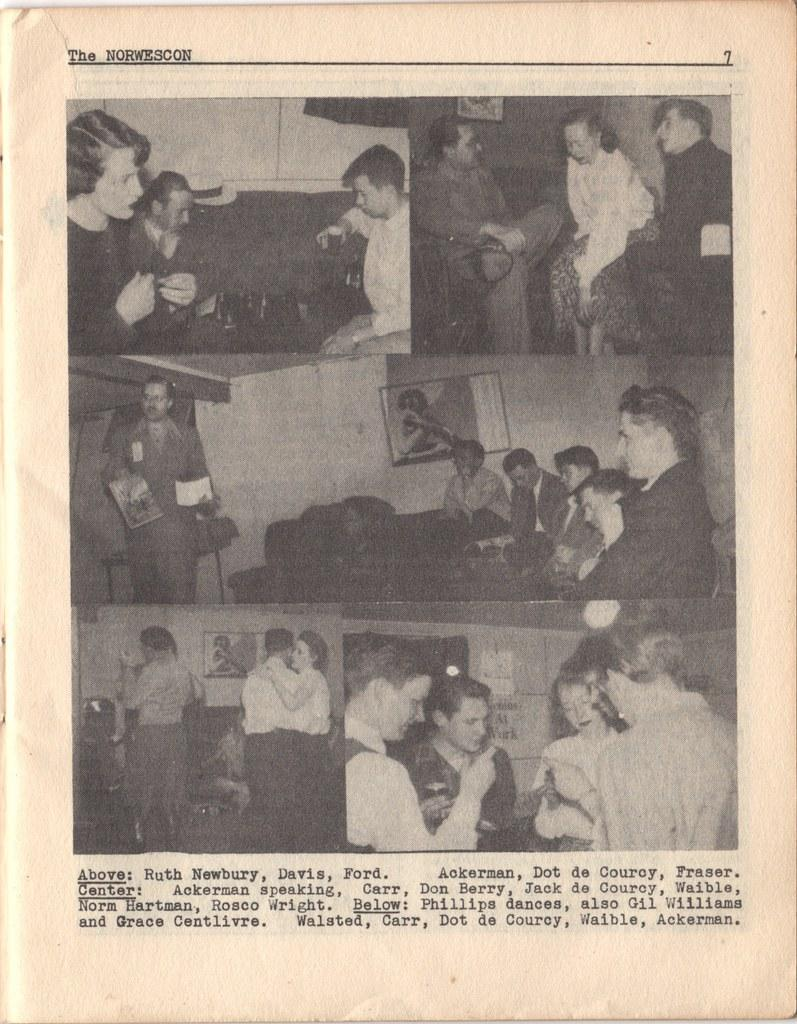What is the main object in the image? There is a paper in the image. What is depicted on the paper? There are people depicted on the paper. What else can be found on the paper besides the images of people? There is written matter on the paper. What type of fruit is being detailed in the image? There is no fruit present in the image; it features a paper with people and written matter. 